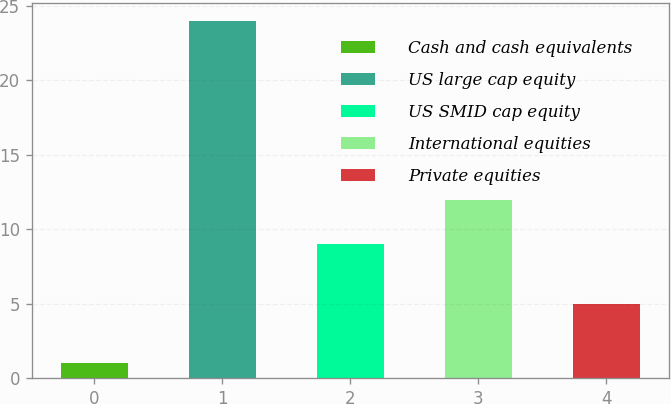Convert chart. <chart><loc_0><loc_0><loc_500><loc_500><bar_chart><fcel>Cash and cash equivalents<fcel>US large cap equity<fcel>US SMID cap equity<fcel>International equities<fcel>Private equities<nl><fcel>1<fcel>24<fcel>9<fcel>12<fcel>5<nl></chart> 